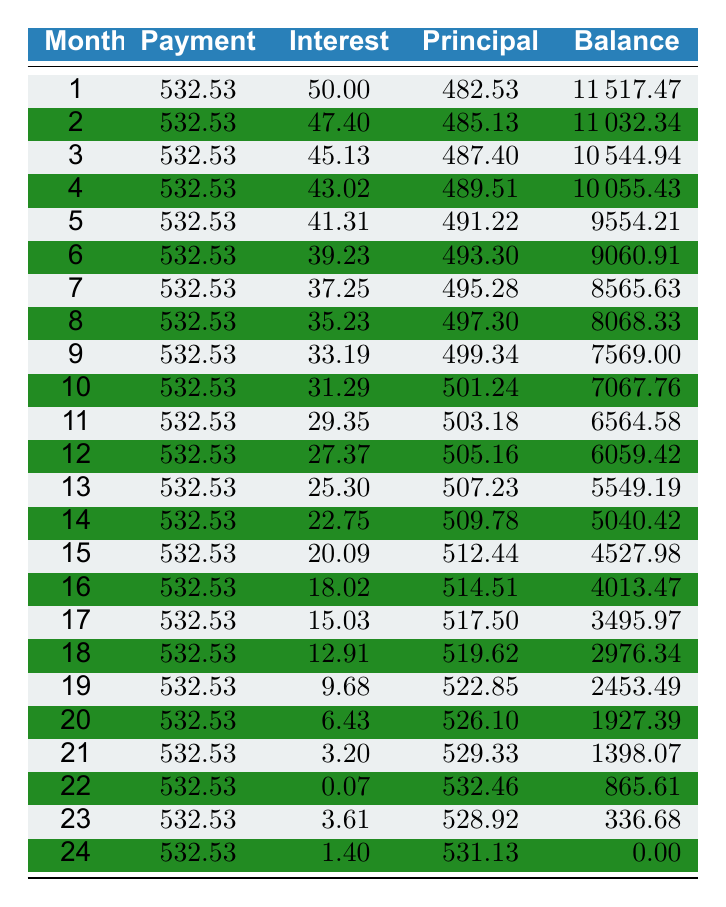What is the total amount paid after 24 months? To find the total amount paid after 24 months, multiply the monthly payment by the number of months: 532.53 * 24 = 12780.72.
Answer: 12780.72 What was the interest paid in the 12th month? The interest paid in the 12th month is directly listed in the table, which shows 27.37.
Answer: 27.37 What is the average principal paid per month over the entire term? To calculate the average principal paid, we sum all the principal payments for 24 months and then divide by 24. The principal paid for each month sums up to 11684.63, so the average is 11684.63 / 24 = 486.02.
Answer: 486.02 Is the interest paid in the 14th month greater than the interest paid in the 16th month? Looking at the table, the interest paid in the 14th month is 22.75, while the interest paid in the 16th month is 18.02. Since 22.75 is greater than 18.02, the answer is yes.
Answer: Yes How much principal was paid down in the last month compared to the first month? The principal paid in the first month is 482.53, and in the last month is 531.13. The difference is 531.13 - 482.53 = 48.60, meaning the principal paid down in the last month is greater by this amount.
Answer: 48.60 What is the remaining balance after the 6th month? The table shows that the remaining balance after the 6th month is 9060.91 as indicated in the respective row for month 6.
Answer: 9060.91 What was the total interest paid over the entire term? To find the total interest paid over the term, we need to add all the interest payments for each month, which sums up to 301.08.
Answer: 301.08 Was any month there more than 500 in principal paid? By reviewing the table, the principal paid in several months (1st-15th) exceeds 500, indicating that there were months where the principal paid exceeded this amount. Therefore, the statement is true.
Answer: Yes How does the principal paid in the 24th month compare to the average over the entire term? The principal paid in the 24th month is 531.13. As calculated earlier, the average principal paid per month is 486.02, and since 531.13 is greater than 486.02, the comparison shows it exceeds the average.
Answer: Greater 